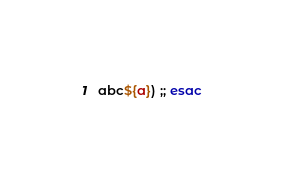Convert code to text. <code><loc_0><loc_0><loc_500><loc_500><_Bash_>abc${a}) ;; esac
</code> 